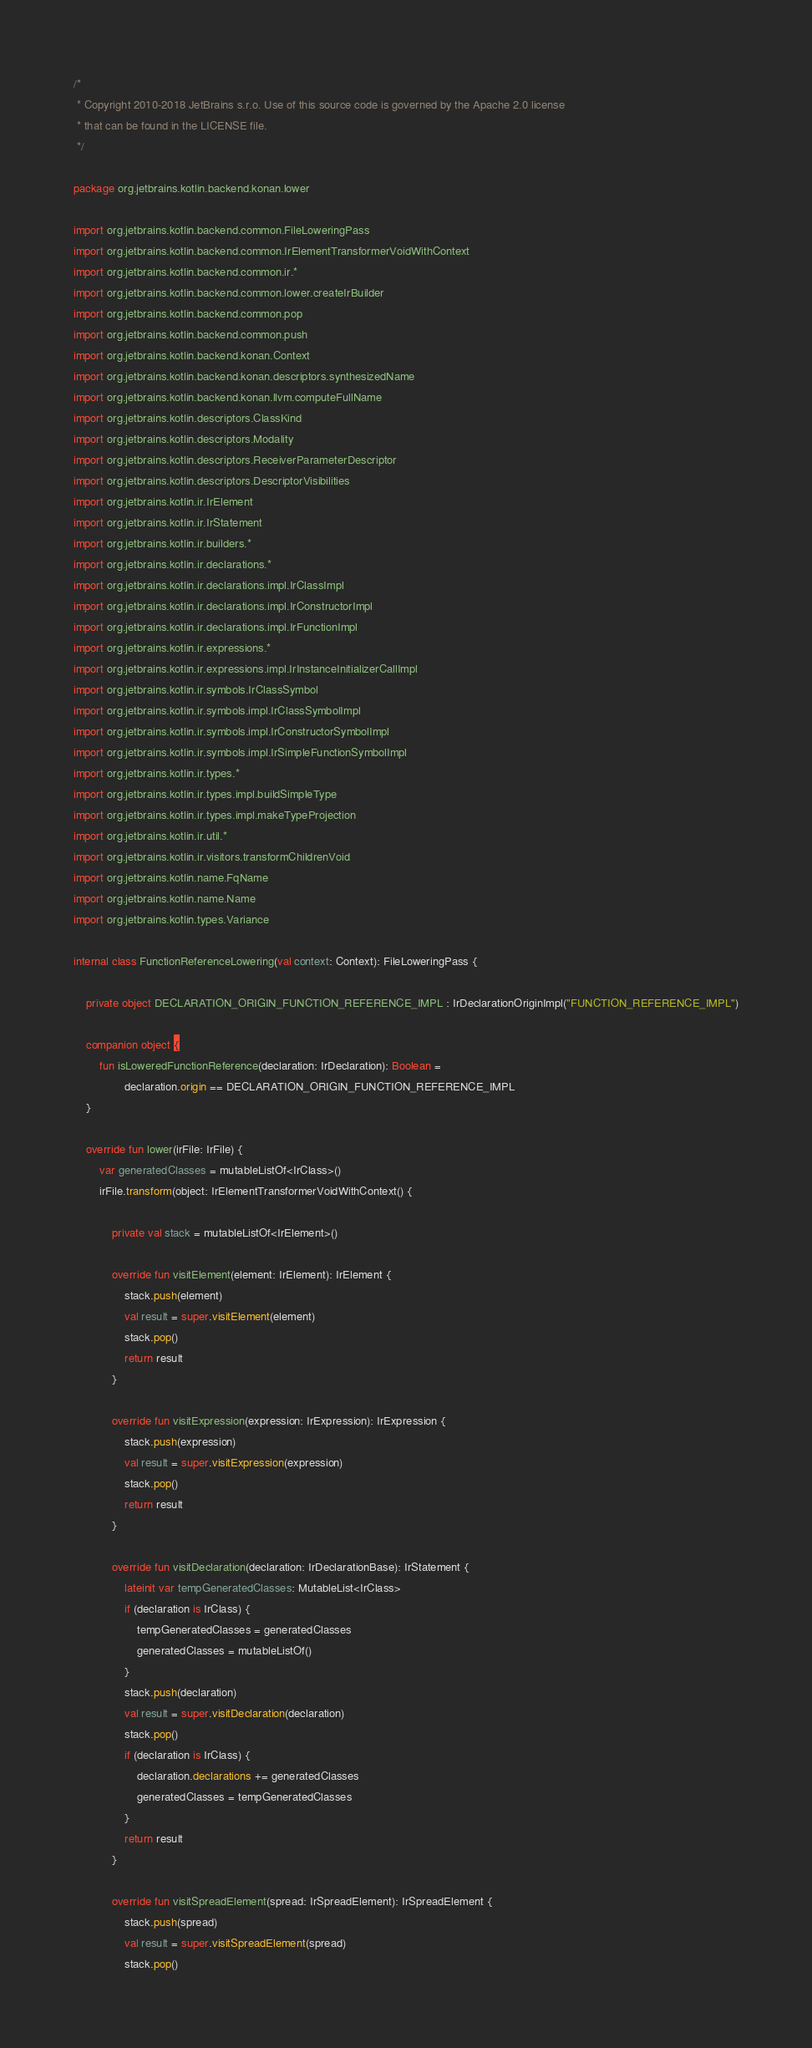Convert code to text. <code><loc_0><loc_0><loc_500><loc_500><_Kotlin_>/*
 * Copyright 2010-2018 JetBrains s.r.o. Use of this source code is governed by the Apache 2.0 license
 * that can be found in the LICENSE file.
 */

package org.jetbrains.kotlin.backend.konan.lower

import org.jetbrains.kotlin.backend.common.FileLoweringPass
import org.jetbrains.kotlin.backend.common.IrElementTransformerVoidWithContext
import org.jetbrains.kotlin.backend.common.ir.*
import org.jetbrains.kotlin.backend.common.lower.createIrBuilder
import org.jetbrains.kotlin.backend.common.pop
import org.jetbrains.kotlin.backend.common.push
import org.jetbrains.kotlin.backend.konan.Context
import org.jetbrains.kotlin.backend.konan.descriptors.synthesizedName
import org.jetbrains.kotlin.backend.konan.llvm.computeFullName
import org.jetbrains.kotlin.descriptors.ClassKind
import org.jetbrains.kotlin.descriptors.Modality
import org.jetbrains.kotlin.descriptors.ReceiverParameterDescriptor
import org.jetbrains.kotlin.descriptors.DescriptorVisibilities
import org.jetbrains.kotlin.ir.IrElement
import org.jetbrains.kotlin.ir.IrStatement
import org.jetbrains.kotlin.ir.builders.*
import org.jetbrains.kotlin.ir.declarations.*
import org.jetbrains.kotlin.ir.declarations.impl.IrClassImpl
import org.jetbrains.kotlin.ir.declarations.impl.IrConstructorImpl
import org.jetbrains.kotlin.ir.declarations.impl.IrFunctionImpl
import org.jetbrains.kotlin.ir.expressions.*
import org.jetbrains.kotlin.ir.expressions.impl.IrInstanceInitializerCallImpl
import org.jetbrains.kotlin.ir.symbols.IrClassSymbol
import org.jetbrains.kotlin.ir.symbols.impl.IrClassSymbolImpl
import org.jetbrains.kotlin.ir.symbols.impl.IrConstructorSymbolImpl
import org.jetbrains.kotlin.ir.symbols.impl.IrSimpleFunctionSymbolImpl
import org.jetbrains.kotlin.ir.types.*
import org.jetbrains.kotlin.ir.types.impl.buildSimpleType
import org.jetbrains.kotlin.ir.types.impl.makeTypeProjection
import org.jetbrains.kotlin.ir.util.*
import org.jetbrains.kotlin.ir.visitors.transformChildrenVoid
import org.jetbrains.kotlin.name.FqName
import org.jetbrains.kotlin.name.Name
import org.jetbrains.kotlin.types.Variance

internal class FunctionReferenceLowering(val context: Context): FileLoweringPass {

    private object DECLARATION_ORIGIN_FUNCTION_REFERENCE_IMPL : IrDeclarationOriginImpl("FUNCTION_REFERENCE_IMPL")

    companion object {
        fun isLoweredFunctionReference(declaration: IrDeclaration): Boolean =
                declaration.origin == DECLARATION_ORIGIN_FUNCTION_REFERENCE_IMPL
    }

    override fun lower(irFile: IrFile) {
        var generatedClasses = mutableListOf<IrClass>()
        irFile.transform(object: IrElementTransformerVoidWithContext() {

            private val stack = mutableListOf<IrElement>()

            override fun visitElement(element: IrElement): IrElement {
                stack.push(element)
                val result = super.visitElement(element)
                stack.pop()
                return result
            }

            override fun visitExpression(expression: IrExpression): IrExpression {
                stack.push(expression)
                val result = super.visitExpression(expression)
                stack.pop()
                return result
            }

            override fun visitDeclaration(declaration: IrDeclarationBase): IrStatement {
                lateinit var tempGeneratedClasses: MutableList<IrClass>
                if (declaration is IrClass) {
                    tempGeneratedClasses = generatedClasses
                    generatedClasses = mutableListOf()
                }
                stack.push(declaration)
                val result = super.visitDeclaration(declaration)
                stack.pop()
                if (declaration is IrClass) {
                    declaration.declarations += generatedClasses
                    generatedClasses = tempGeneratedClasses
                }
                return result
            }

            override fun visitSpreadElement(spread: IrSpreadElement): IrSpreadElement {
                stack.push(spread)
                val result = super.visitSpreadElement(spread)
                stack.pop()</code> 